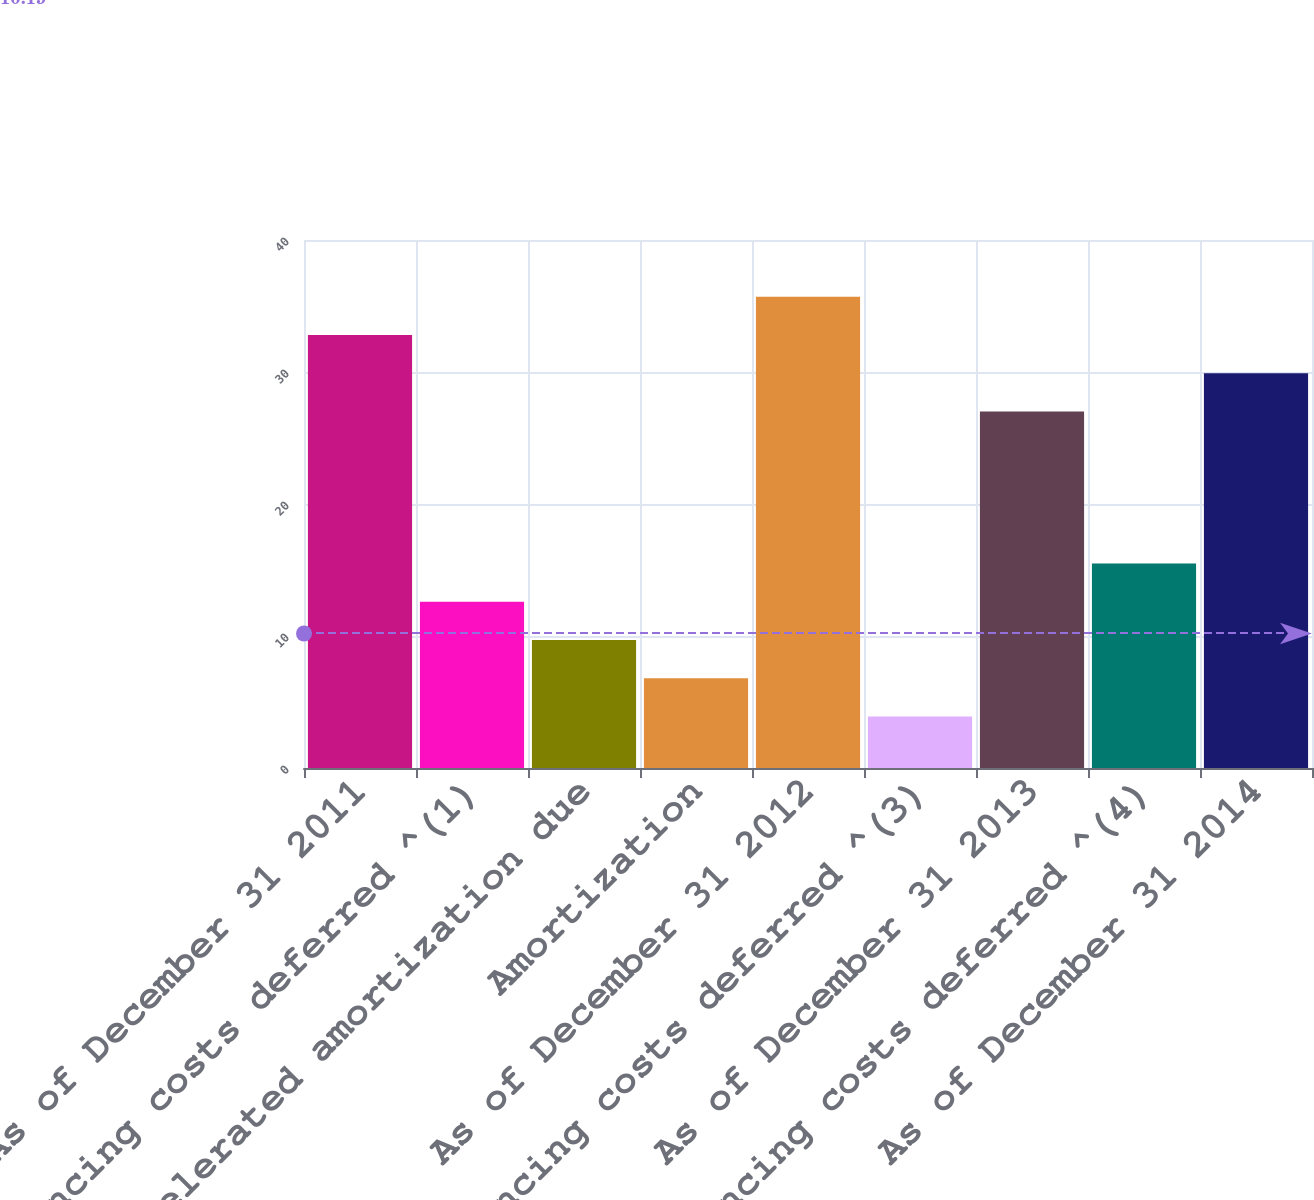<chart> <loc_0><loc_0><loc_500><loc_500><bar_chart><fcel>As of December 31 2011<fcel>Financing costs deferred ^(1)<fcel>Accelerated amortization due<fcel>Amortization<fcel>As of December 31 2012<fcel>Financing costs deferred ^(3)<fcel>As of December 31 2013<fcel>Financing costs deferred ^(4)<fcel>As of December 31 2014<nl><fcel>32.8<fcel>12.6<fcel>9.7<fcel>6.8<fcel>35.7<fcel>3.9<fcel>27<fcel>15.5<fcel>29.9<nl></chart> 